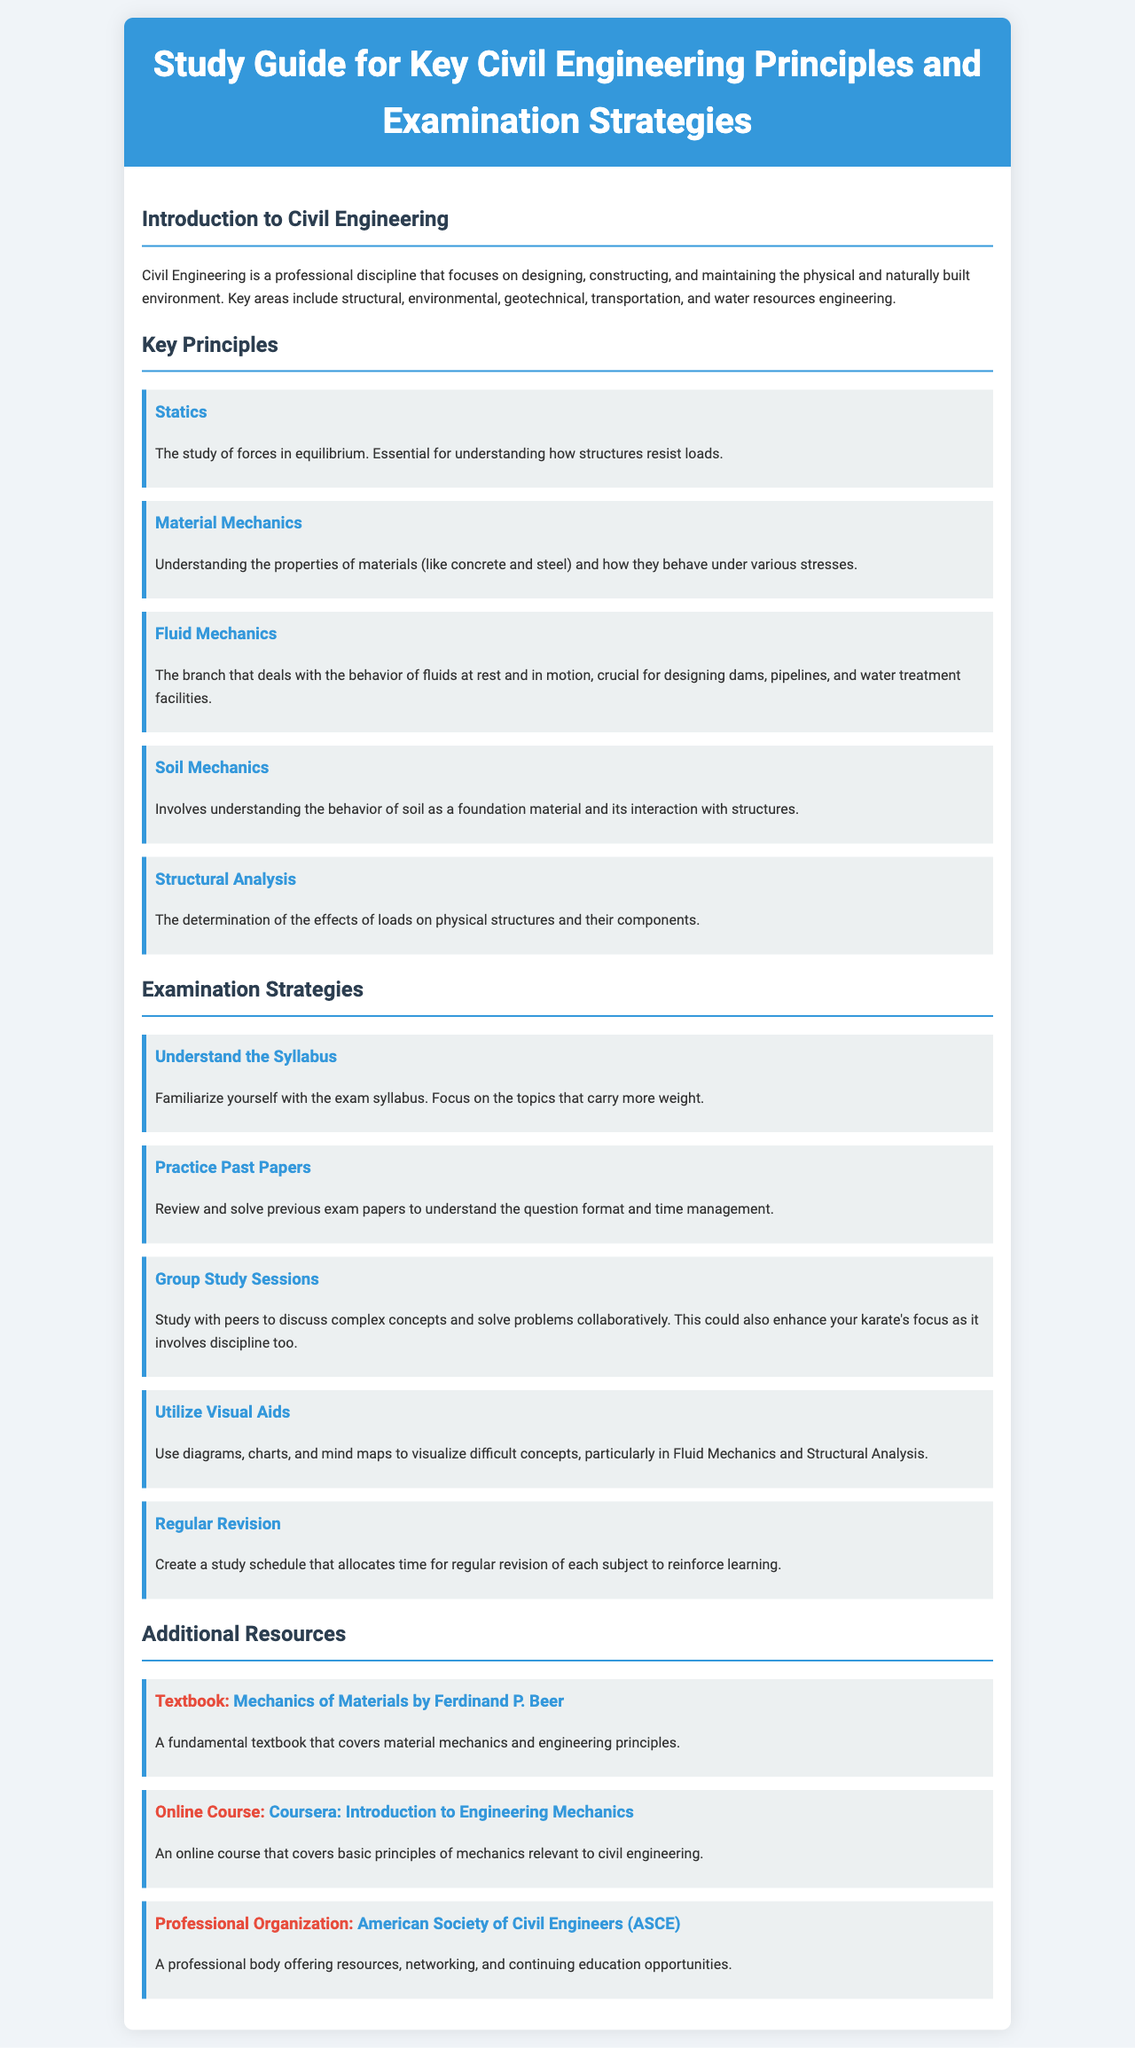What is the title of the document? The title is displayed prominently at the top of the document, which is "Study Guide for Key Civil Engineering Principles and Examination Strategies."
Answer: Study Guide for Key Civil Engineering Principles and Examination Strategies How many key principles are listed in the document? The document clearly enumerates the key principles in the "Key Principles" section. Upon counting, there are five principles mentioned.
Answer: 5 What principle involves understanding forces in equilibrium? The principle related to forces in equilibrium is specified in the "Key Principles" section.
Answer: Statics What does the strategy "Utilize Visual Aids" recommend? The document elaborates on the strategy by suggesting the use of diagrams, charts, and mind maps to visualize concepts.
Answer: Diagrams, charts, and mind maps Which organization is mentioned as a resource for civil engineers? Among the "Additional Resources," the document identifies a professional organization that supports civil engineers.
Answer: American Society of Civil Engineers (ASCE) What is the recommended textbook for material mechanics? In the "Additional Resources" section, the document specifies a textbook that covers the fundamentals of material mechanics.
Answer: Mechanics of Materials by Ferdinand P. Beer Why is group study beneficial according to the document? The document mentions that group study sessions facilitate discussion of complex concepts and collaborative problem-solving, enhancing focus.
Answer: Enhance focus What is a key examination strategy highlighted in the document? The document presents various strategies, and one central focus is understanding the syllabus.
Answer: Understand the Syllabus 